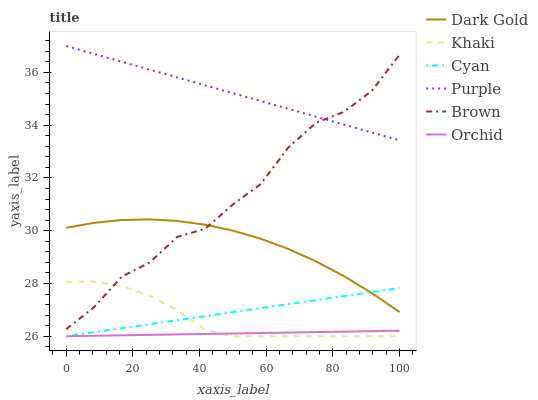Does Orchid have the minimum area under the curve?
Answer yes or no. Yes. Does Purple have the maximum area under the curve?
Answer yes or no. Yes. Does Khaki have the minimum area under the curve?
Answer yes or no. No. Does Khaki have the maximum area under the curve?
Answer yes or no. No. Is Orchid the smoothest?
Answer yes or no. Yes. Is Brown the roughest?
Answer yes or no. Yes. Is Khaki the smoothest?
Answer yes or no. No. Is Khaki the roughest?
Answer yes or no. No. Does Dark Gold have the lowest value?
Answer yes or no. No. Does Purple have the highest value?
Answer yes or no. Yes. Does Khaki have the highest value?
Answer yes or no. No. Is Cyan less than Purple?
Answer yes or no. Yes. Is Purple greater than Khaki?
Answer yes or no. Yes. Does Khaki intersect Orchid?
Answer yes or no. Yes. Is Khaki less than Orchid?
Answer yes or no. No. Is Khaki greater than Orchid?
Answer yes or no. No. Does Cyan intersect Purple?
Answer yes or no. No. 